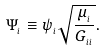Convert formula to latex. <formula><loc_0><loc_0><loc_500><loc_500>\Psi _ { _ { i } } \equiv \psi _ { _ { i } } \sqrt { \frac { \mu _ { _ { i } } } { G _ { _ { i i } } } } .</formula> 